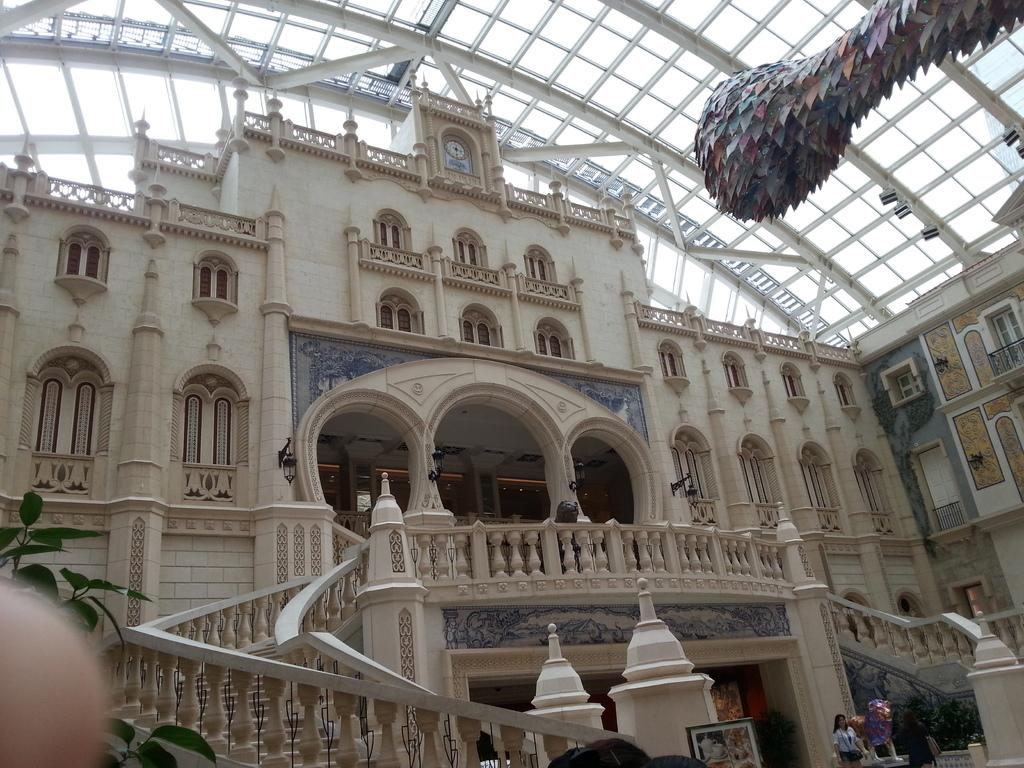What type of structure is present in the image? There is a building in the image. What are some features of the building? The building has a roof, pillars, windows, and staircases. What can be seen in the background of the image? There are leaves visible in the image. What is the purpose of the frame in the image? The frame is likely used to support or hold something, but its specific purpose is not clear from the facts provided. Can you describe the people in the image? There are people present in the image, but their actions or characteristics are not specified in the facts. What are some of the objects visible in the image? There are a few objects in the image, but their specific nature is not mentioned in the facts. What is the value of the ball in the image? There is no ball present in the image, so its value cannot be determined. 